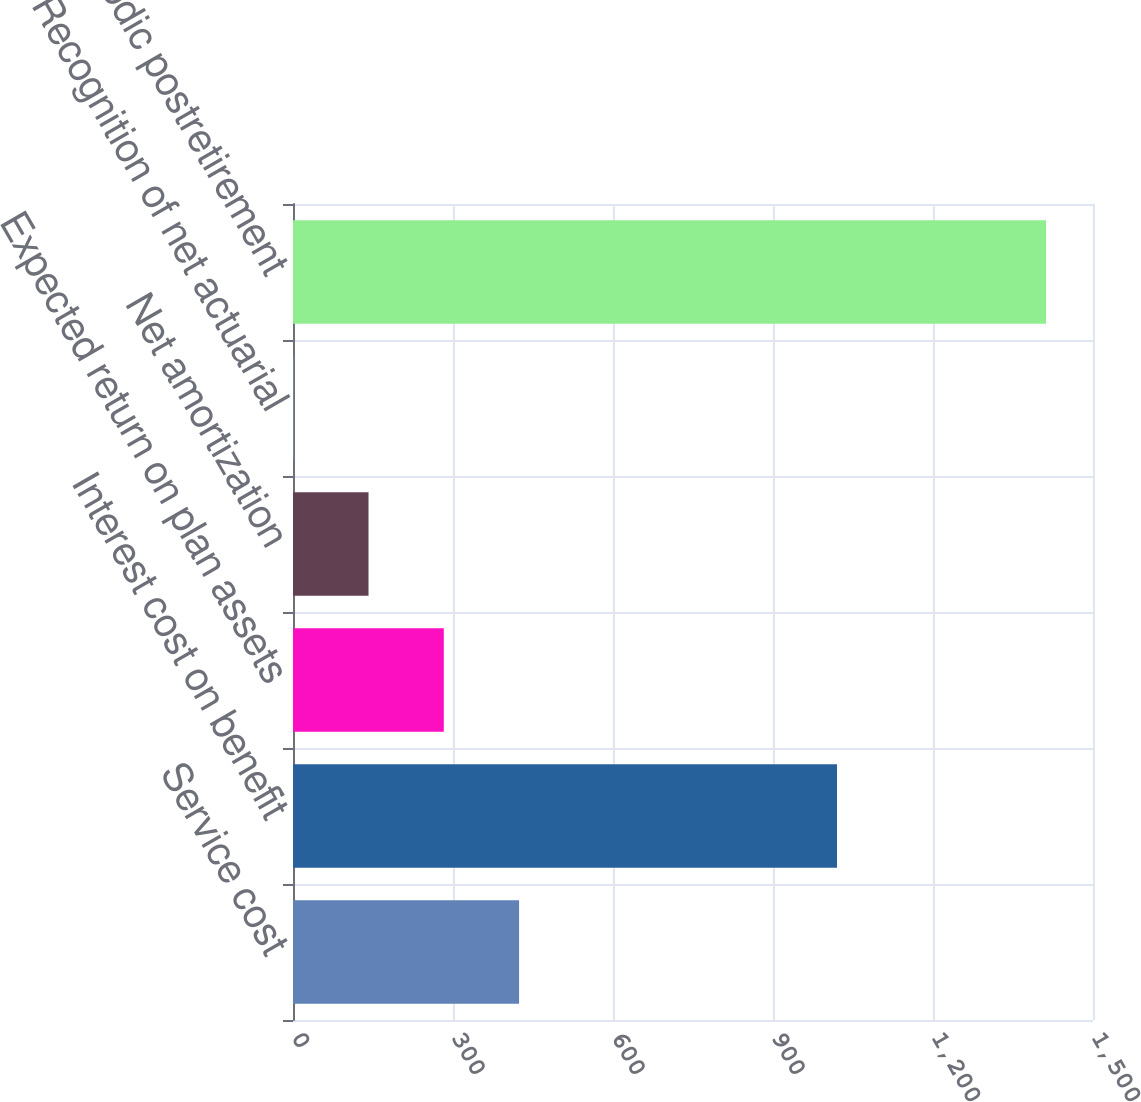<chart> <loc_0><loc_0><loc_500><loc_500><bar_chart><fcel>Service cost<fcel>Interest cost on benefit<fcel>Expected return on plan assets<fcel>Net amortization<fcel>Recognition of net actuarial<fcel>Net periodic postretirement<nl><fcel>423.9<fcel>1020<fcel>282.75<fcel>141.6<fcel>0.45<fcel>1412<nl></chart> 